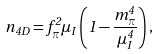<formula> <loc_0><loc_0><loc_500><loc_500>n _ { 4 D } = f _ { \pi } ^ { 2 } \mu _ { I } \left ( 1 - \frac { m _ { \pi } ^ { 4 } } { \mu _ { I } ^ { 4 } } \right ) ,</formula> 